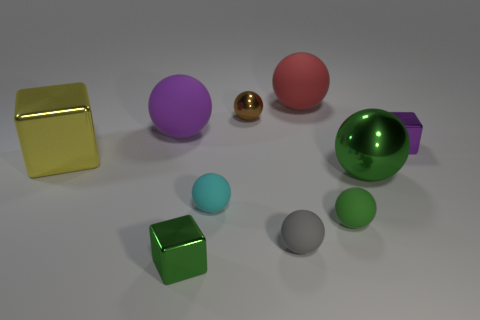Subtract 1 blocks. How many blocks are left? 2 Subtract all green blocks. How many blocks are left? 2 Subtract all tiny metal cubes. How many cubes are left? 1 Subtract all brown blocks. How many yellow balls are left? 0 Add 4 red metal blocks. How many red metal blocks exist? 4 Subtract 0 gray cylinders. How many objects are left? 10 Subtract all cubes. How many objects are left? 7 Subtract all brown blocks. Subtract all yellow spheres. How many blocks are left? 3 Subtract all red matte balls. Subtract all purple rubber spheres. How many objects are left? 8 Add 4 small cyan rubber balls. How many small cyan rubber balls are left? 5 